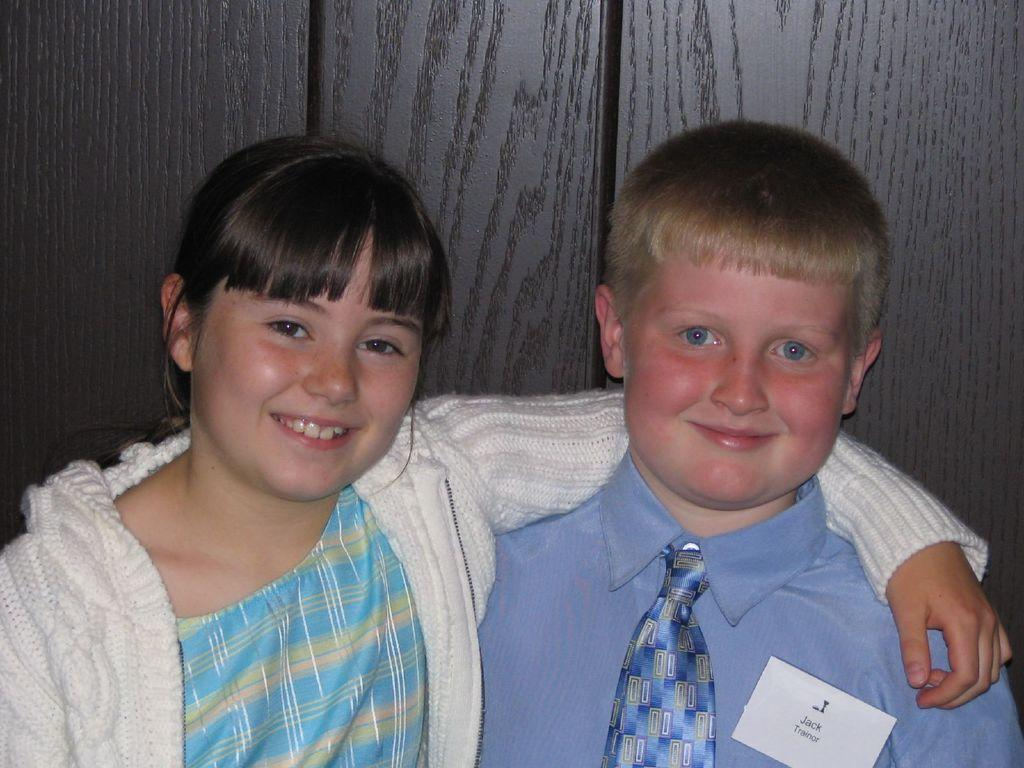Who are the people in the image? There is a boy and a girl in the image. What are the expressions on their faces? Both the boy and the girl are smiling in the image. Is there anything on the boy's shirt? Yes, there is a paper on the boy's shirt. What credit score does the boy have in the image? There is no information about credit scores in the image, as it features a boy and a girl smiling. What discovery was made by the girl in the image? There is no indication of a discovery being made in the image; it simply shows the boy and the girl smiling. 